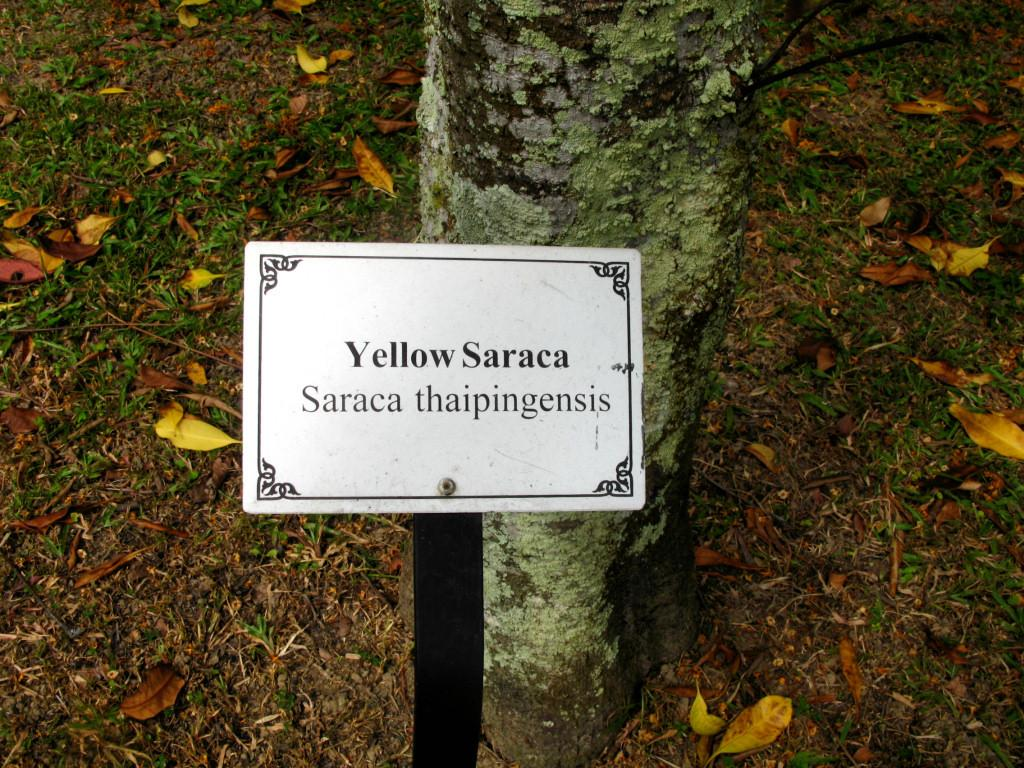What is the main object in the image? There is a yellow color board in the image. How is the color board positioned? The board is fixed to a pole. What can be seen on the color board? There is text on the board. What natural element is present in the image? There is a tree trunk in the image. What is on the ground in the image? Dried leaves are present on the grassy ground. What type of silver fork can be seen in the image? There is no silver fork present in the image. What disease is mentioned on the color board in the image? The text on the color board is not mentioned, so it cannot be determined if any diseases are mentioned. 